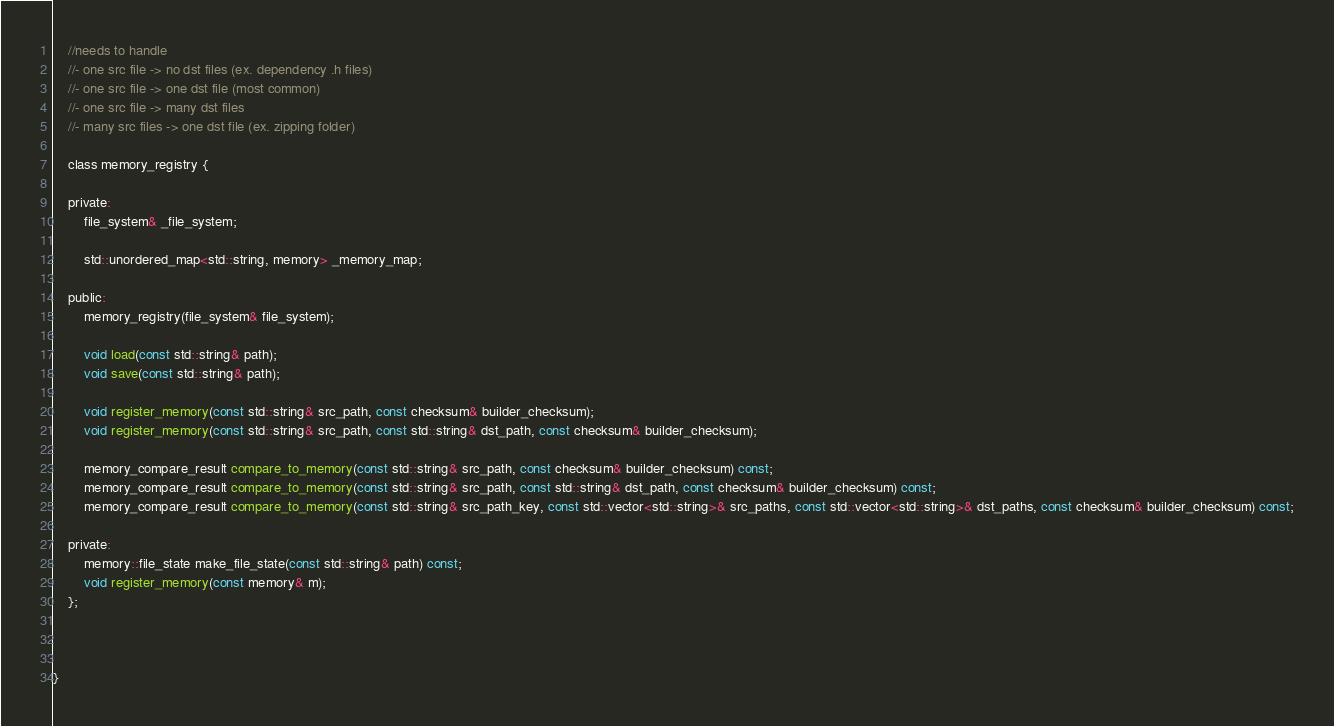<code> <loc_0><loc_0><loc_500><loc_500><_C_>	//needs to handle
	//- one src file -> no dst files (ex. dependency .h files)
	//- one src file -> one dst file (most common)
	//- one src file -> many dst files
	//- many src files -> one dst file (ex. zipping folder)

	class memory_registry {

	private:
		file_system& _file_system;

		std::unordered_map<std::string, memory> _memory_map;

	public:
		memory_registry(file_system& file_system);

		void load(const std::string& path);
		void save(const std::string& path);

		void register_memory(const std::string& src_path, const checksum& builder_checksum);
		void register_memory(const std::string& src_path, const std::string& dst_path, const checksum& builder_checksum);

		memory_compare_result compare_to_memory(const std::string& src_path, const checksum& builder_checksum) const;
		memory_compare_result compare_to_memory(const std::string& src_path, const std::string& dst_path, const checksum& builder_checksum) const;
		memory_compare_result compare_to_memory(const std::string& src_path_key, const std::vector<std::string>& src_paths, const std::vector<std::string>& dst_paths, const checksum& builder_checksum) const;

	private:
		memory::file_state make_file_state(const std::string& path) const;
		void register_memory(const memory& m);
	};



}</code> 